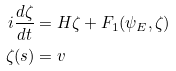Convert formula to latex. <formula><loc_0><loc_0><loc_500><loc_500>i \frac { d \zeta } { d t } & = H \zeta + F _ { 1 } ( \psi _ { E } , \zeta ) \\ \zeta ( s ) & = v</formula> 